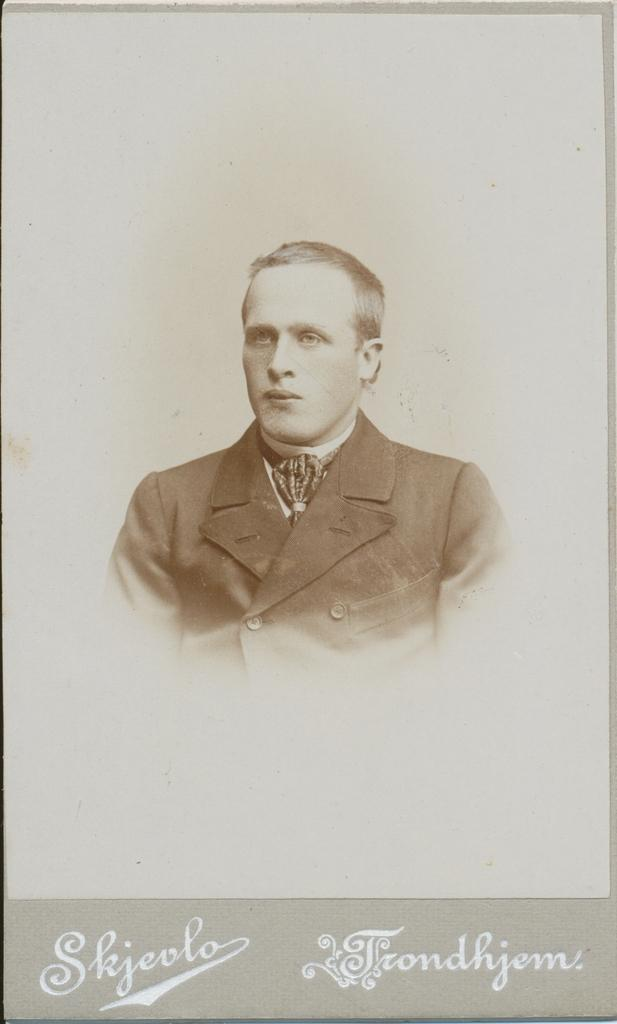What is present in the image related to visual communication? There is a poster in the image. What can be seen on the poster? The poster has an image of a person and texts. What is the color of the background on the poster? The background of the poster is gray in color. What type of songs can be heard playing from the hospital in the image? There is no hospital or songs present in the image; it only features a poster with an image of a person and texts. 